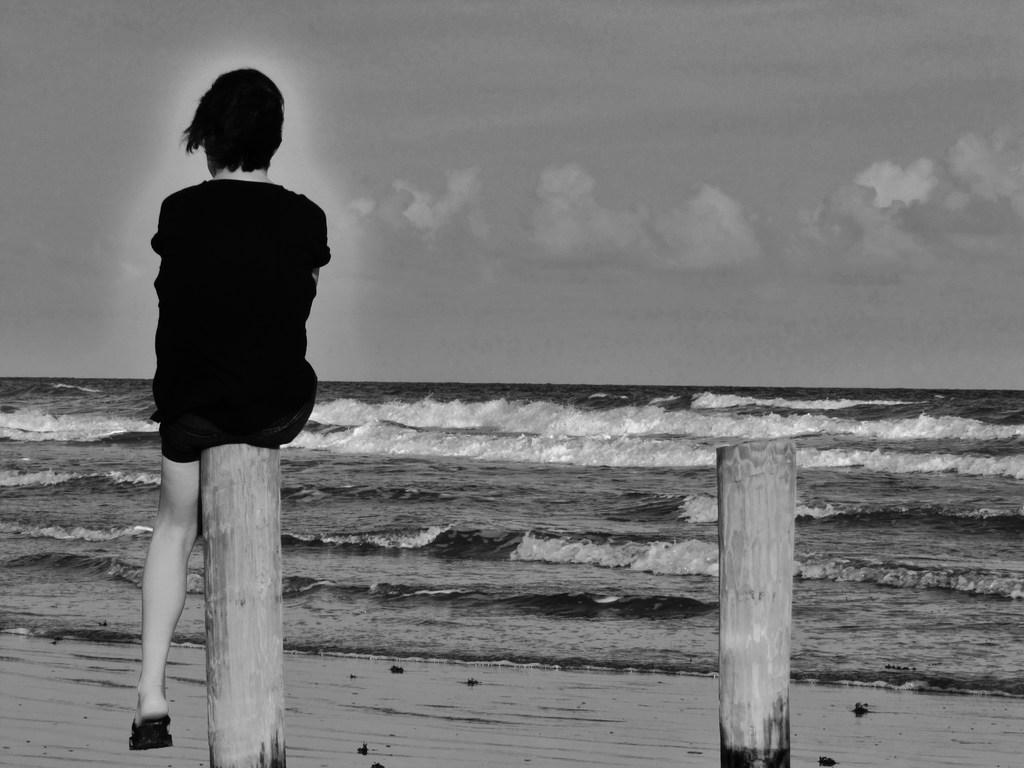What objects can be seen in the front of the image? There are wooden poles in the front of the image. What is the person in the image doing? There is a person sitting on one of the poles. What can be seen in the distance behind the poles? There is an ocean in the background of the image. How would you describe the weather in the image? The sky is cloudy in the image. What type of mitten is the person wearing in the image? There is no mitten visible in the image; the person is sitting on a wooden pole with no visible clothing or accessories. 